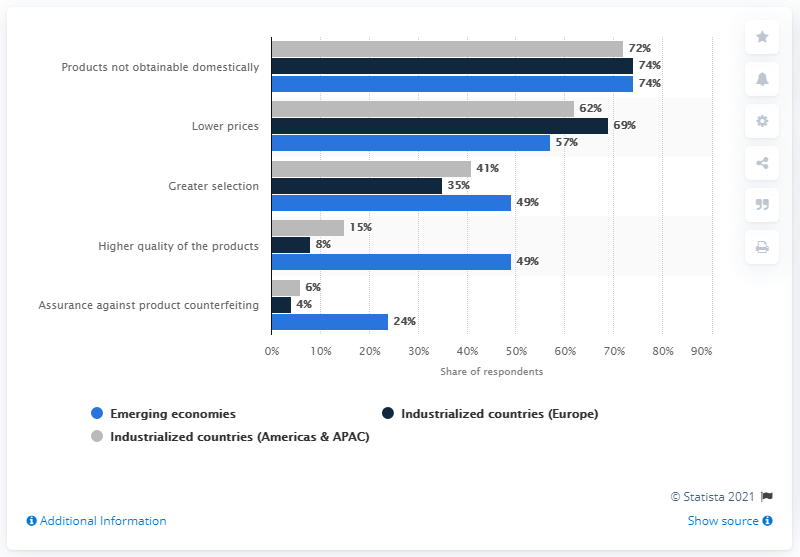Specify some key components in this picture. The leading reason for emerging economies is the lack of availability of products within their own country. The top three reasons for emerging economies make up a combined percentage of 180%. 